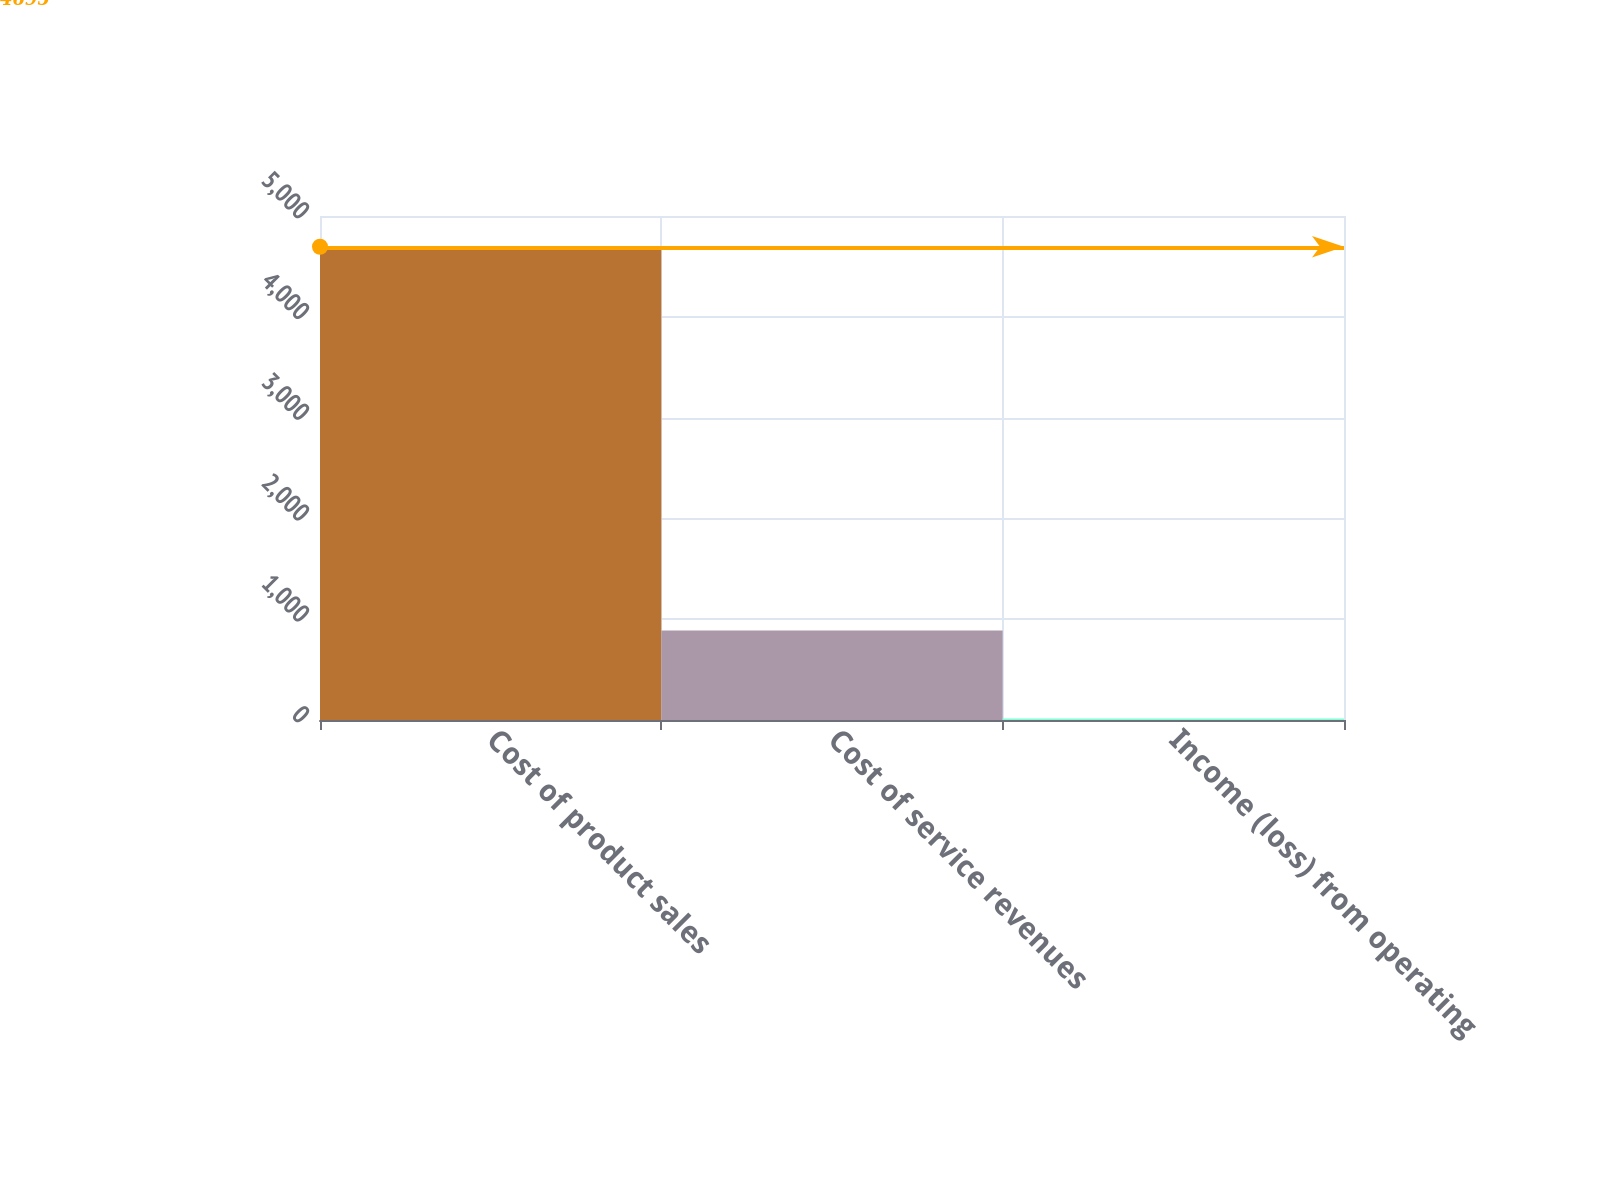Convert chart. <chart><loc_0><loc_0><loc_500><loc_500><bar_chart><fcel>Cost of product sales<fcel>Cost of service revenues<fcel>Income (loss) from operating<nl><fcel>4695<fcel>888<fcel>14<nl></chart> 